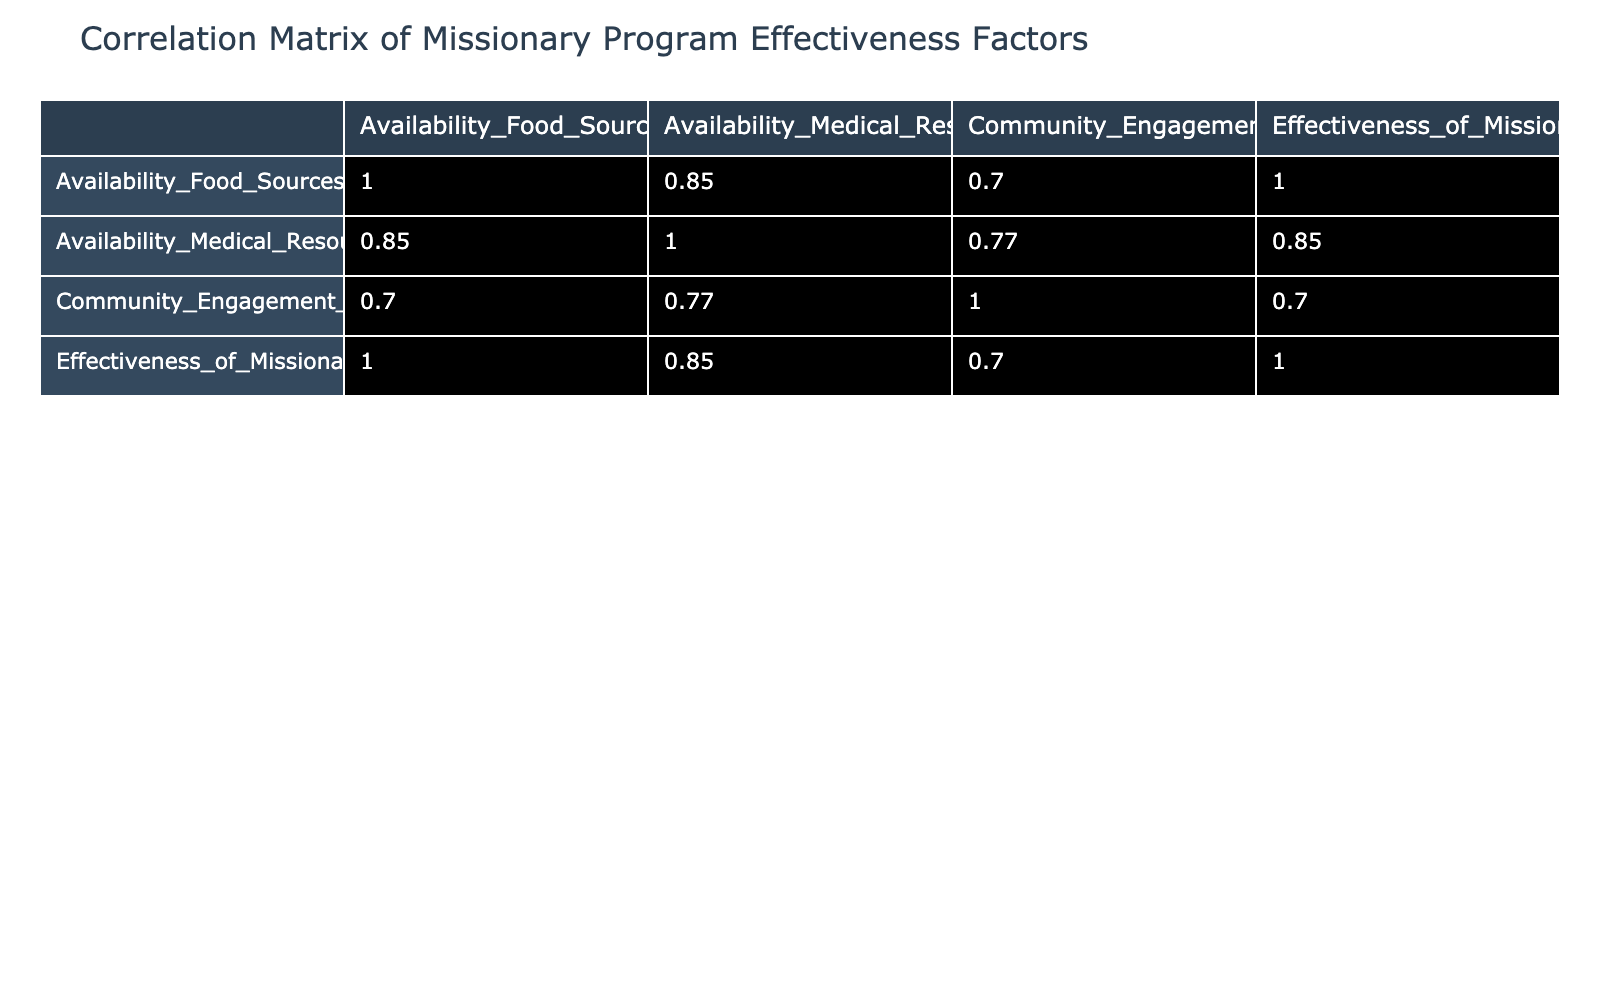What is the correlation coefficient between the availability of food sources and the effectiveness of missionary programs? The correlation coefficient between the availability of food sources and the effectiveness of missionary programs can be found in the table. It shows that the correlation is 0.9, which indicates a strong positive relationship between these two variables.
Answer: 0.9 Is the effectiveness of missionary programs highest in North America? By looking at the effectiveness scores in the table, North America has a score of 10, which is the highest among all locations listed. Therefore, the statement is true.
Answer: Yes What is the average availability of medical resources score across all locations? To find the average, we sum all the medical resources scores (5 + 6 + 7 + 8 + 4 + 5 + 2 + 9 = 46) and divide by the number of locations (8). So, 46 divided by 8 equals 5.75.
Answer: 5.75 Which location has the lowest score in community engagement? The community engagement scores can be checked, and Central Africa has the lowest score of 4 among all locations listed in the table.
Answer: Central Africa What is the difference between the availability of food sources in Latin America and South Asia? The scores for food sources are 9 for Latin America and 5 for South Asia. To find the difference, we subtract 5 from 9, which equals 4.
Answer: 4 Does higher availability of medical resources generally lead to higher effectiveness of missionary programs? Looking at the correlation coefficient between medical resources and effectiveness, scoring 0.6 suggests a positive relationship. This implies that generally, higher availability does lead to higher effectiveness.
Answer: Yes What is the sum of availability of food sources scores for all locations? To calculate the sum of food sources scores, we add them up: 8 + 7 + 6 + 9 + 5 + 4 + 3 + 10 = 52.
Answer: 52 Which two locations show the highest correlation between the availability of food sources and community engagement? The correlation between these two variables is inferred from their scores across locations, with the strongest relationship indicated between Latin America (9 for food, 6 for engagement) and Sub-Saharan Africa (8 for food, 7 for engagement). The specific correlation value is 0.5.
Answer: Latin America and Sub-Saharan Africa 